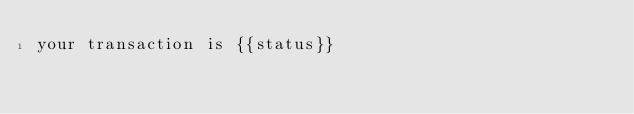<code> <loc_0><loc_0><loc_500><loc_500><_HTML_>your transaction is {{status}}
</code> 